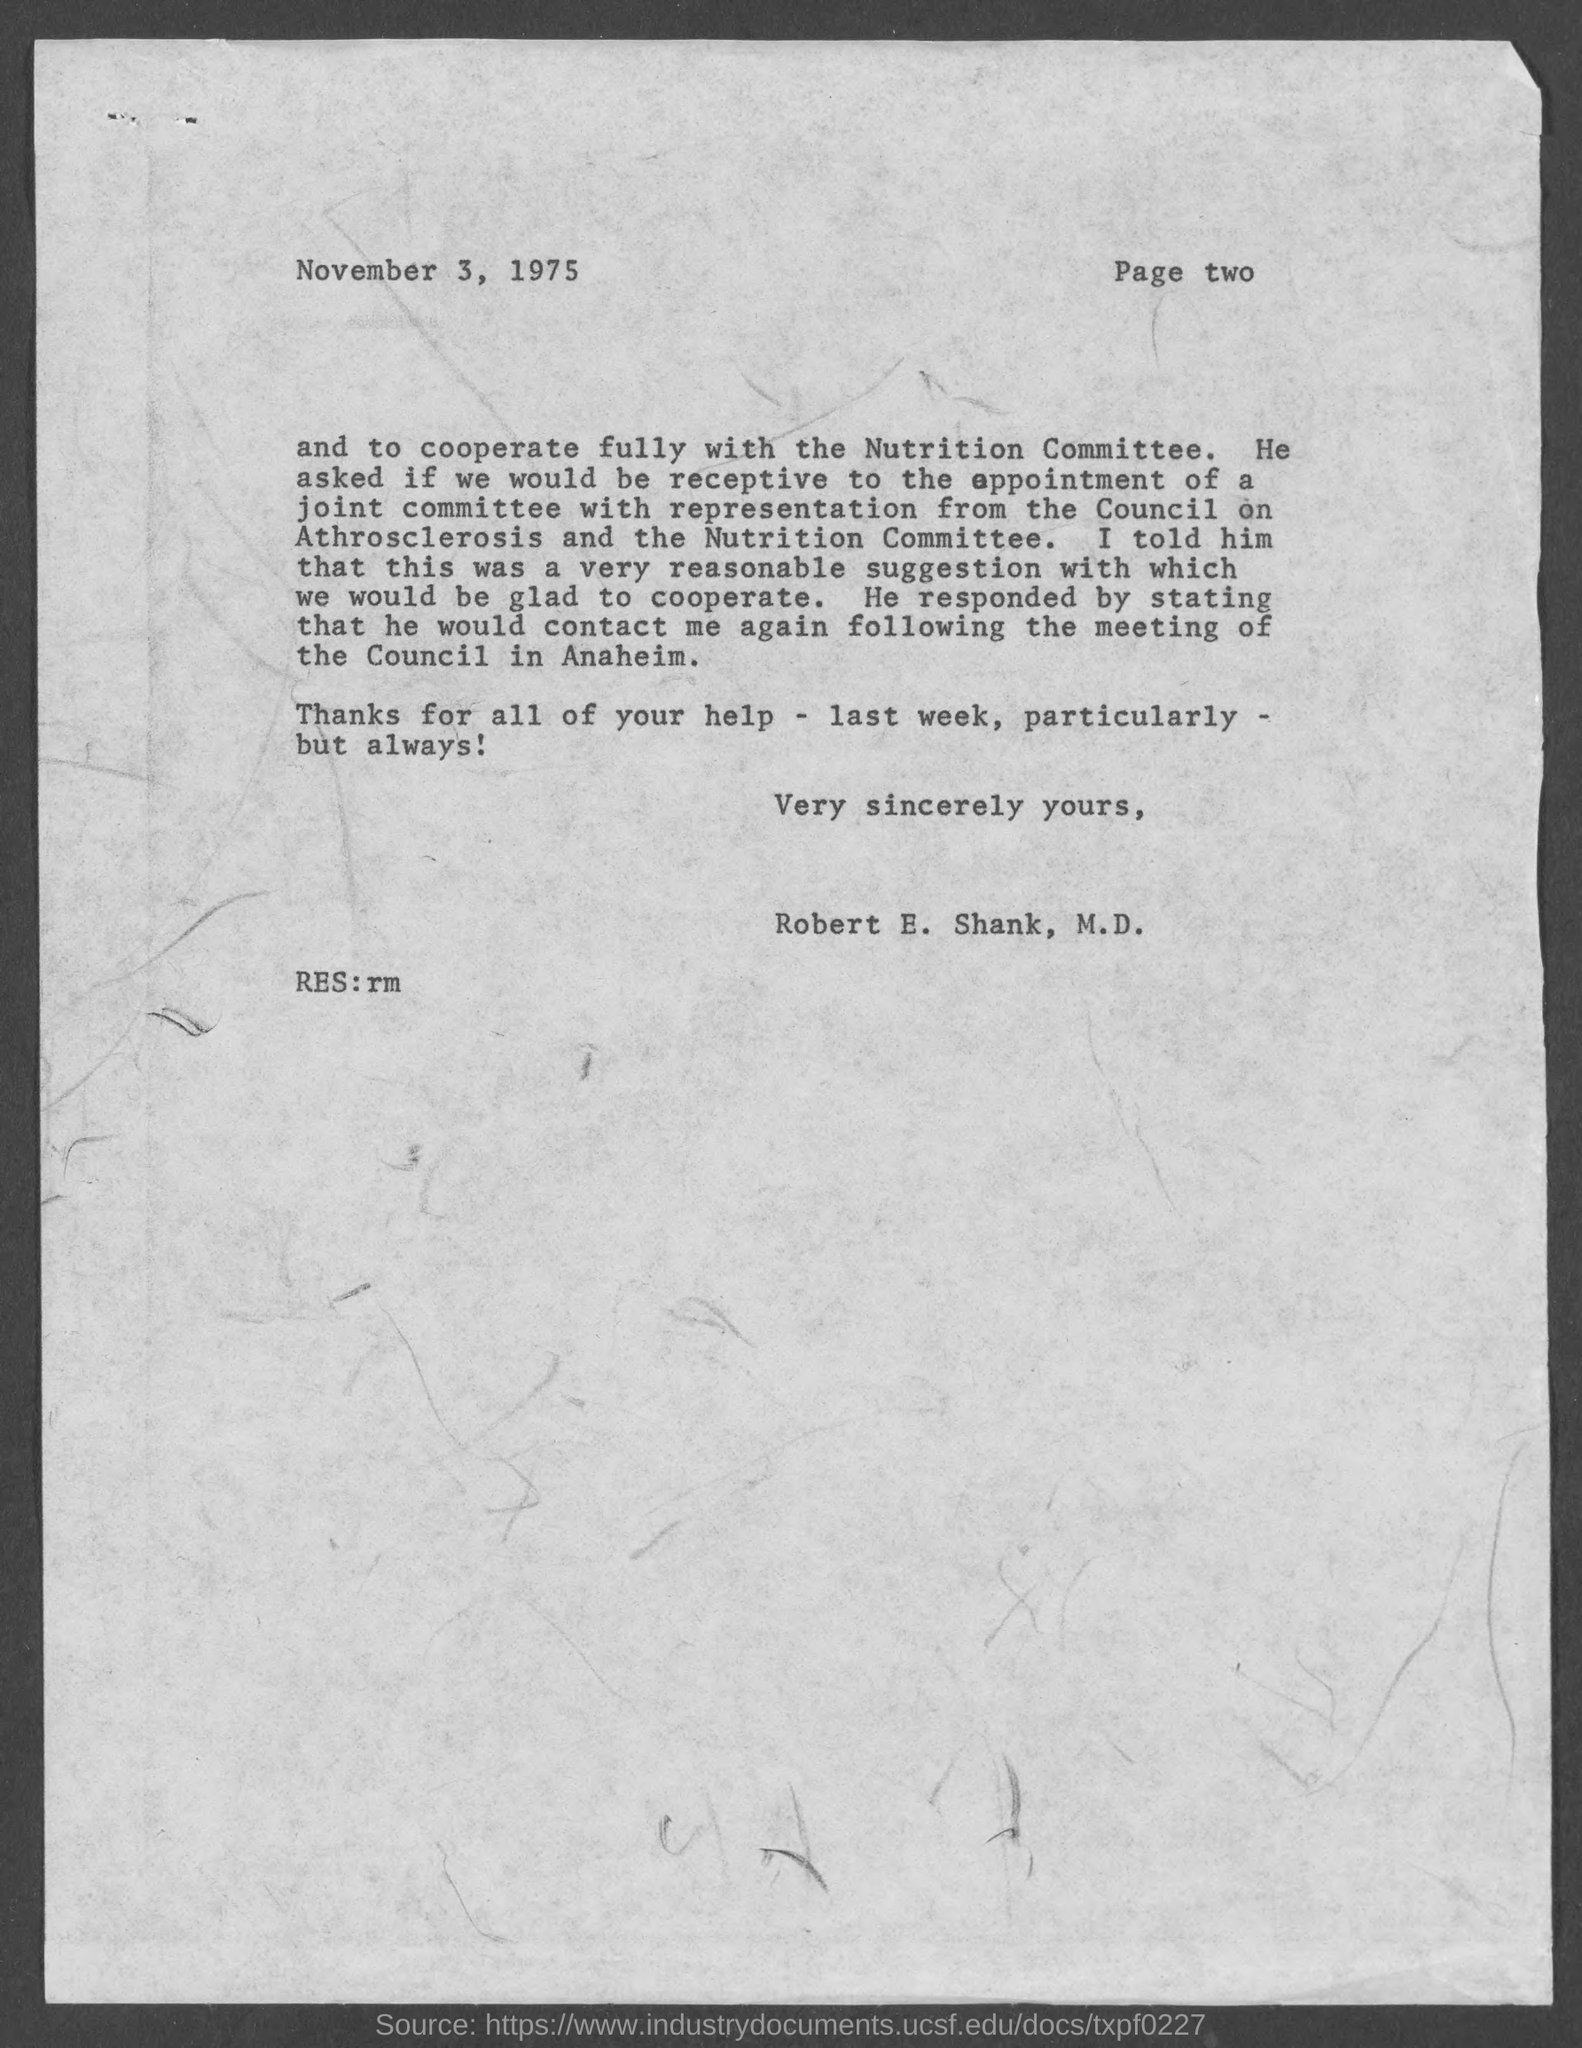What is the date on the document?
Ensure brevity in your answer.  November 3, 1975. Who is this letter from?
Give a very brief answer. Robert e. shank, m.d. 